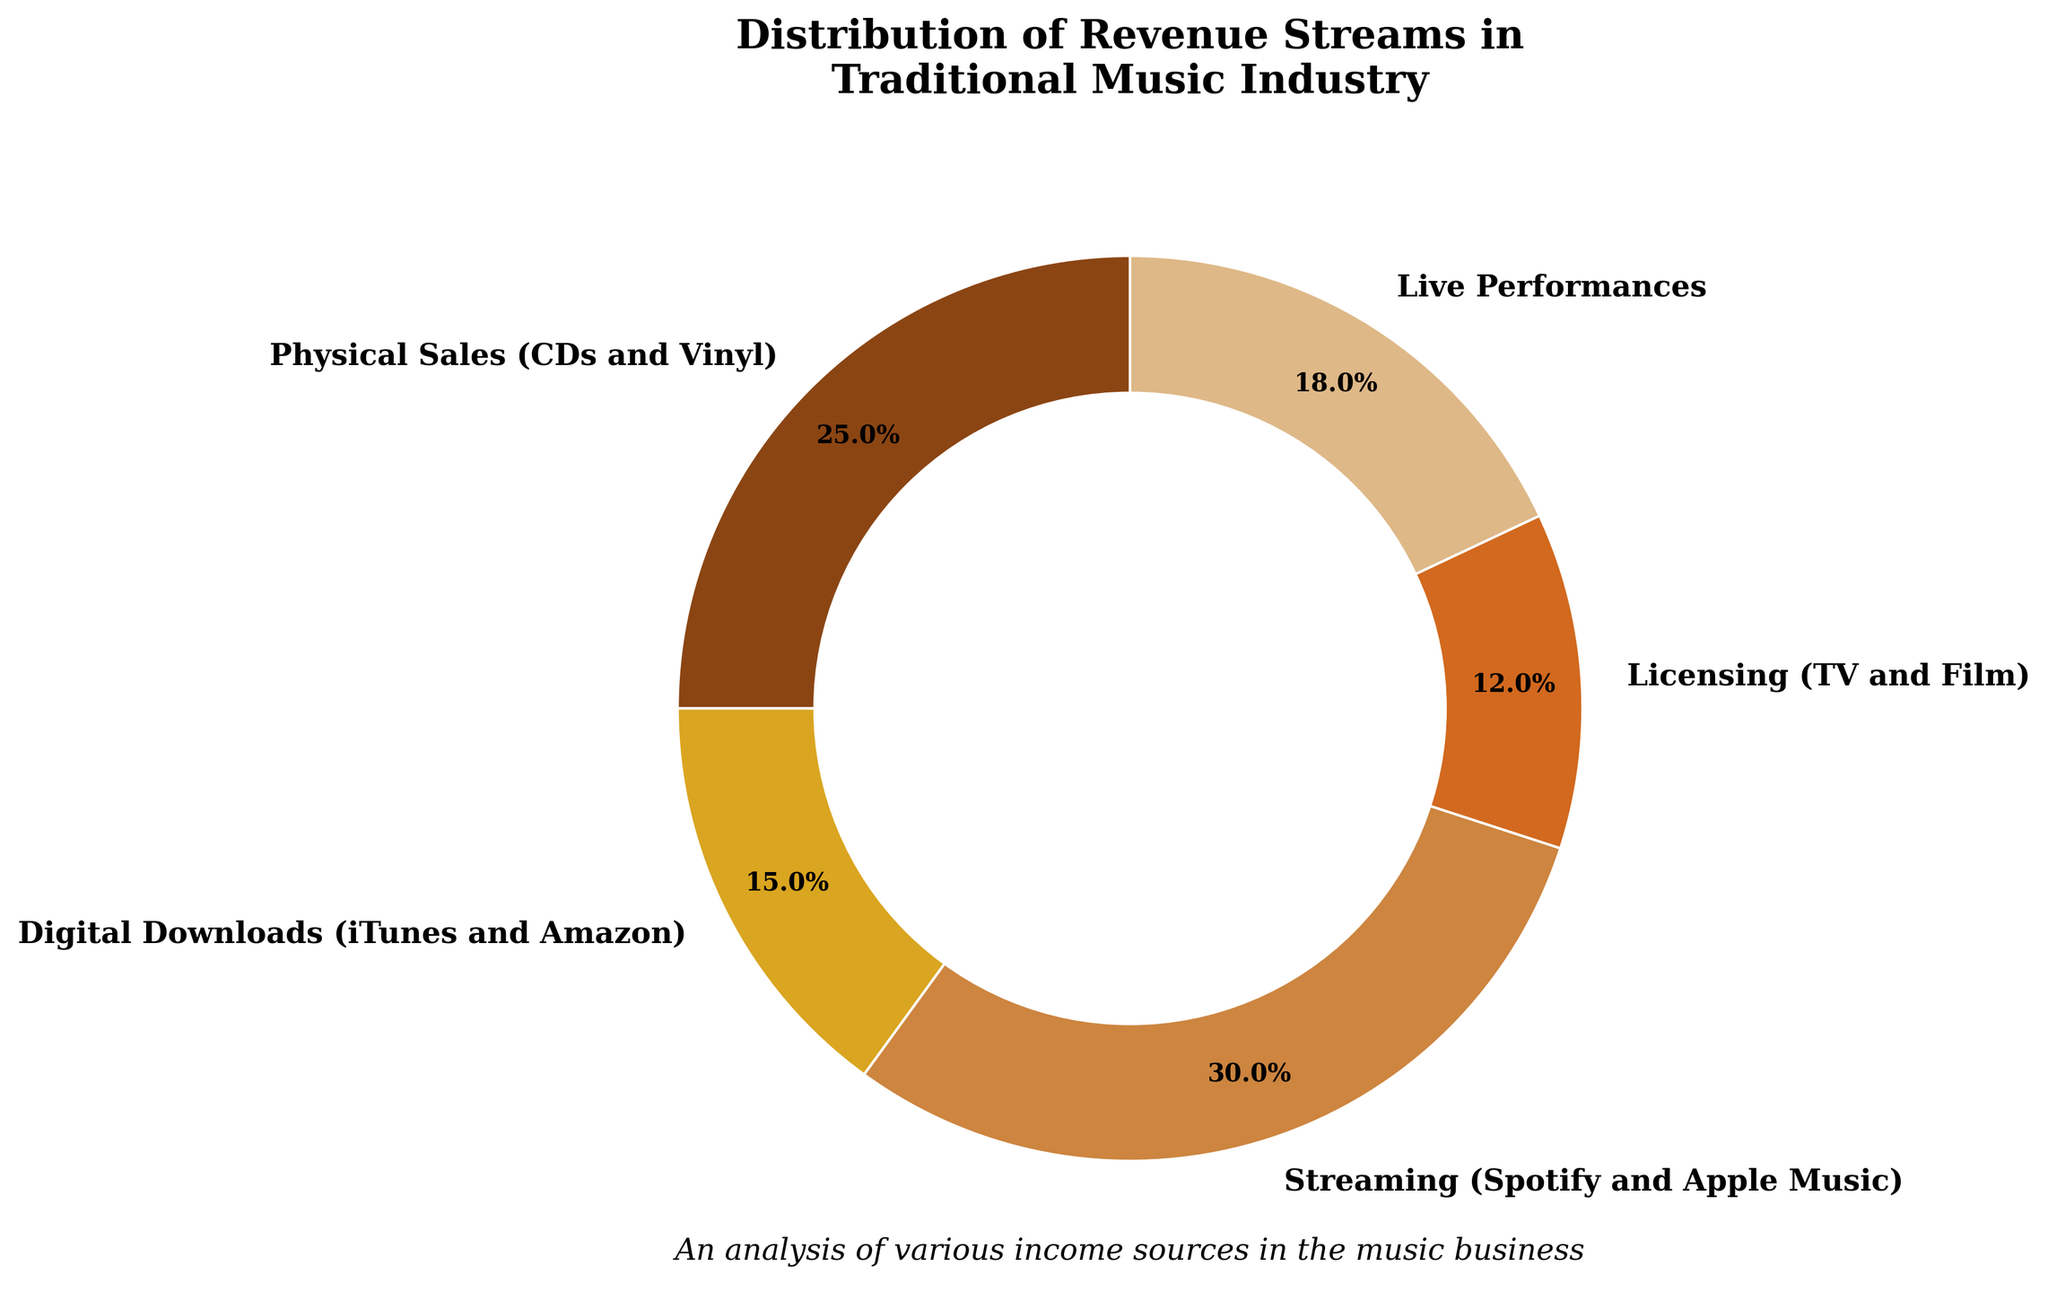Which revenue stream has the highest percentage? The pie chart shows different revenue streams with their respective percentages. The largest segment indicates the highest percentage. Checking the segments, streaming has the highest percentage.
Answer: Streaming How much higher is the percentage of streaming compared to licensing? To find the difference in percentages between streaming and licensing, subtract the percentage of licensing from the percentage of streaming. Streaming is 30% and licensing is 12%, so the difference is 30% - 12%.
Answer: 18% What is the combined percentage of physical sales and digital downloads? To find the combined percentage, add the percentages of physical sales and digital downloads. Physical sales are 25%, and digital downloads are 15%, so the combined percentage is 25% + 15%.
Answer: 40% Which two revenue streams together make up half of the total revenue? To find which two streams together make up 50%, check combinations of the percentages. Streaming (30%) and physical sales (25%) together make up 55%, whereas streaming (30%) and live performances (18%) together make up 48%. Thus, Streaming and physical sales make slightly more than half, while no other combination makes exactly 50%.
Answer: None What is the gap in percentage between the smallest and largest revenue streams? To find the percentage gap between the smallest and largest revenue streams, subtract the smallest percentage from the largest percentage. The largest is streaming at 30%, and the smallest is licensing at 12%, so the gap is 30% - 12%.
Answer: 18% Rank the revenue streams from highest to lowest percentage. Observing and listing the revenue streams in descending order: Streaming (30%), Physical Sales (25%), Live Performances (18%), Digital Downloads (15%), Licensing (12%).
Answer: Streaming > Physical Sales > Live Performances > Digital Downloads > Licensing Which revenue stream segment is represented by the darkest color? By looking at the pie chart’s visual properties, the segment with the darkest color, which is typically a strong brown, is for physical sales.
Answer: Physical Sales What percentage more do physical sales represent compared to live performances? To determine the percentage difference between physical sales and live performances, subtract the live performances percentage from the physical sales percentage. Physical sales are 25% and live performances are 18%, so the difference is 25% - 18%.
Answer: 7% What percentage do digital downloads and licensing together represent? To find the combined percentage of digital downloads and licensing, add their percentages. Digital downloads are 15%, and licensing is 12%, so the combined percentage is 15% + 12%.
Answer: 27% How do the percentages of live performances and digital downloads compare? Comparing the segments for live performances and digital downloads, live performances have a higher percentage. Live performances are 18%, while digital downloads are 15%.
Answer: Live Performances > Digital Downloads 